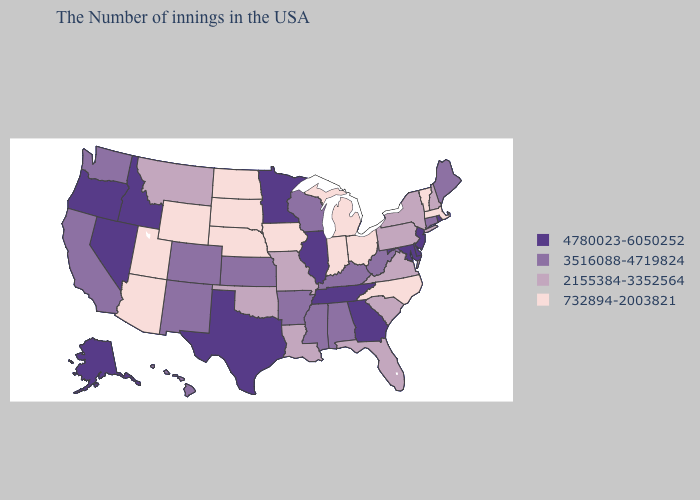What is the highest value in the Northeast ?
Give a very brief answer. 4780023-6050252. Which states hav the highest value in the West?
Give a very brief answer. Idaho, Nevada, Oregon, Alaska. Which states have the lowest value in the Northeast?
Short answer required. Massachusetts, Vermont. What is the lowest value in states that border Vermont?
Be succinct. 732894-2003821. What is the highest value in the MidWest ?
Answer briefly. 4780023-6050252. What is the value of New Mexico?
Keep it brief. 3516088-4719824. What is the lowest value in states that border Arizona?
Be succinct. 732894-2003821. What is the value of Florida?
Concise answer only. 2155384-3352564. What is the value of Texas?
Concise answer only. 4780023-6050252. What is the value of Texas?
Answer briefly. 4780023-6050252. What is the lowest value in the USA?
Answer briefly. 732894-2003821. Which states hav the highest value in the South?
Give a very brief answer. Delaware, Maryland, Georgia, Tennessee, Texas. What is the value of Colorado?
Concise answer only. 3516088-4719824. What is the value of Arkansas?
Be succinct. 3516088-4719824. Does Alabama have the lowest value in the South?
Give a very brief answer. No. 